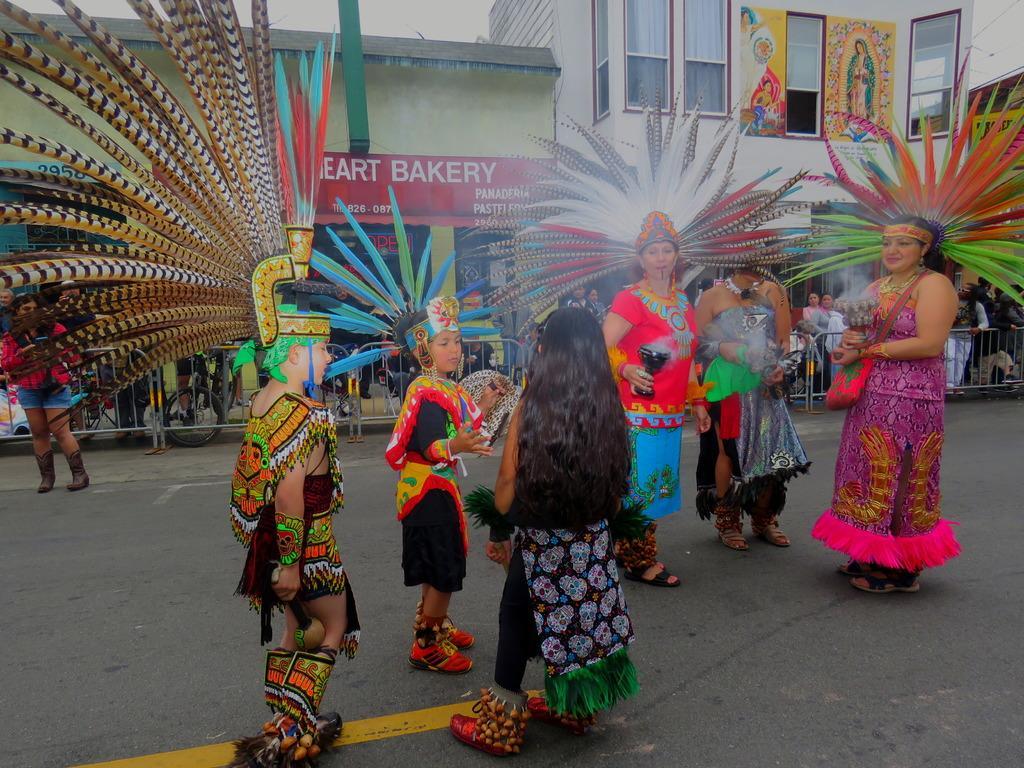Please provide a concise description of this image. In this picture I can see few people in fancy dresses. I can see group of people standing, barriers, buildings, boards and some other objects, and in the background there is the sky. 